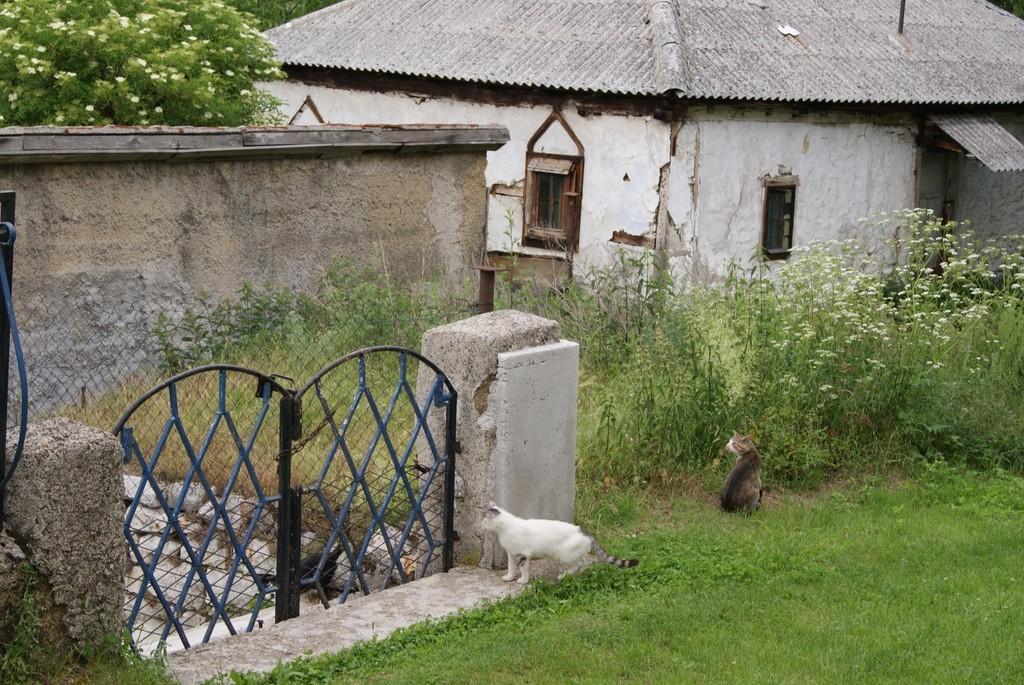Describe this image in one or two sentences. In this image we can see two cats on the grassy land. In the background, we can see a gate, planets, houses and trees. 